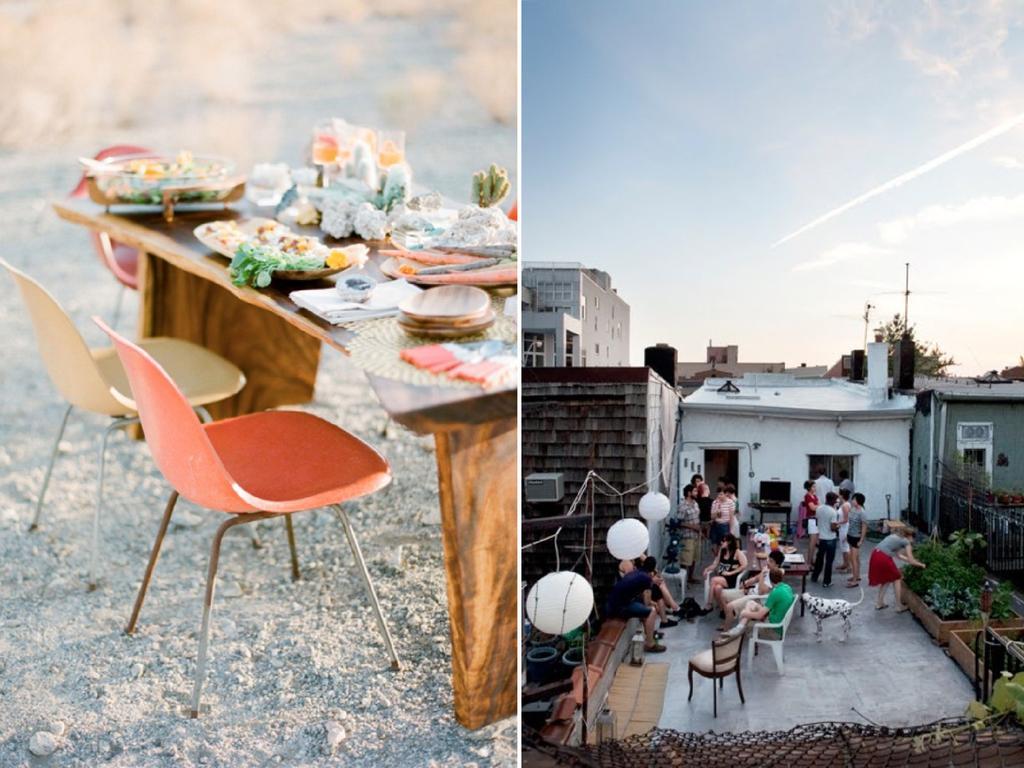Please provide a concise description of this image. In this image there are two different images. On the right there are many people, table, tel vision, window, plants, building and sky. On the left there is a table on that there is plate and some other items, around the table there are chairs. 